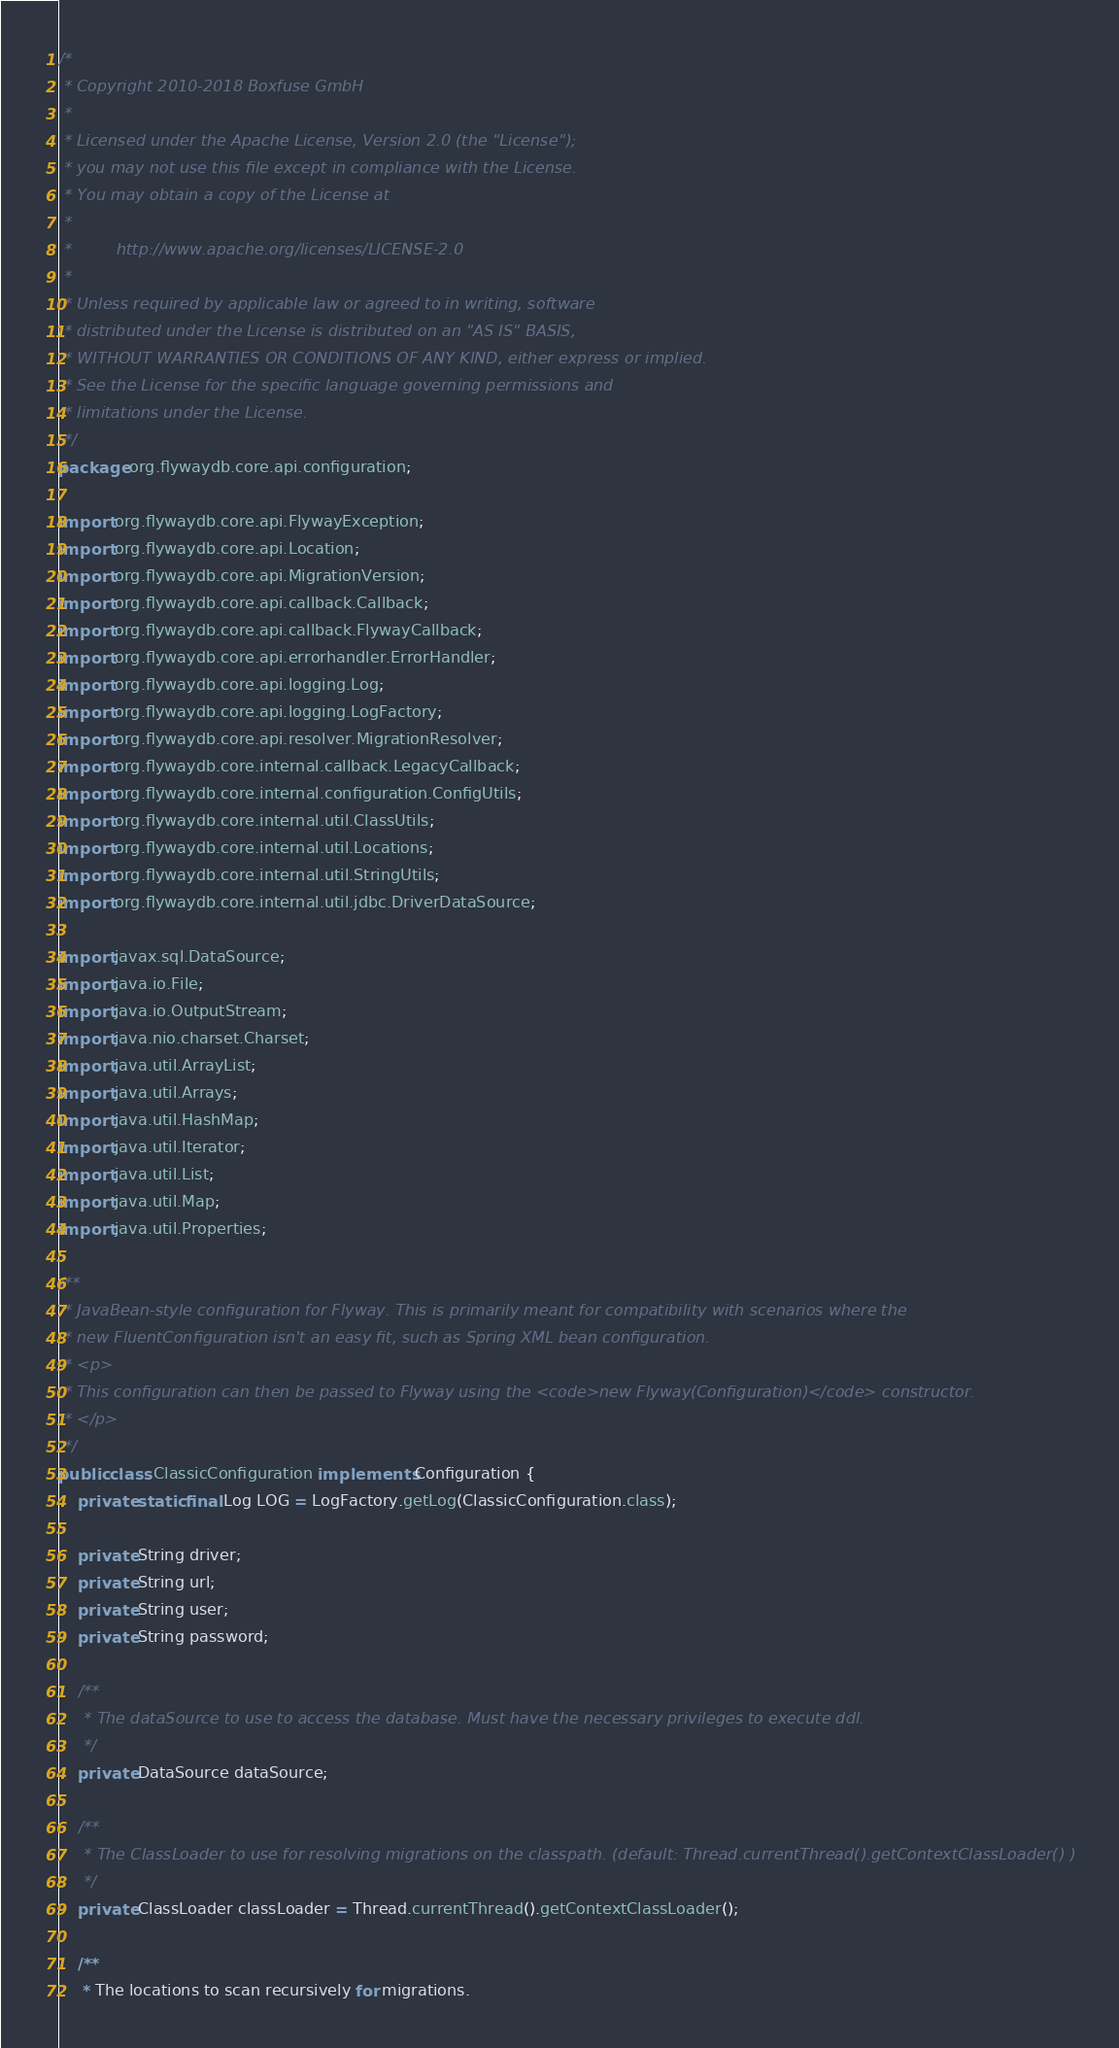Convert code to text. <code><loc_0><loc_0><loc_500><loc_500><_Java_>/*
 * Copyright 2010-2018 Boxfuse GmbH
 *
 * Licensed under the Apache License, Version 2.0 (the "License");
 * you may not use this file except in compliance with the License.
 * You may obtain a copy of the License at
 *
 *         http://www.apache.org/licenses/LICENSE-2.0
 *
 * Unless required by applicable law or agreed to in writing, software
 * distributed under the License is distributed on an "AS IS" BASIS,
 * WITHOUT WARRANTIES OR CONDITIONS OF ANY KIND, either express or implied.
 * See the License for the specific language governing permissions and
 * limitations under the License.
 */
package org.flywaydb.core.api.configuration;

import org.flywaydb.core.api.FlywayException;
import org.flywaydb.core.api.Location;
import org.flywaydb.core.api.MigrationVersion;
import org.flywaydb.core.api.callback.Callback;
import org.flywaydb.core.api.callback.FlywayCallback;
import org.flywaydb.core.api.errorhandler.ErrorHandler;
import org.flywaydb.core.api.logging.Log;
import org.flywaydb.core.api.logging.LogFactory;
import org.flywaydb.core.api.resolver.MigrationResolver;
import org.flywaydb.core.internal.callback.LegacyCallback;
import org.flywaydb.core.internal.configuration.ConfigUtils;
import org.flywaydb.core.internal.util.ClassUtils;
import org.flywaydb.core.internal.util.Locations;
import org.flywaydb.core.internal.util.StringUtils;
import org.flywaydb.core.internal.util.jdbc.DriverDataSource;

import javax.sql.DataSource;
import java.io.File;
import java.io.OutputStream;
import java.nio.charset.Charset;
import java.util.ArrayList;
import java.util.Arrays;
import java.util.HashMap;
import java.util.Iterator;
import java.util.List;
import java.util.Map;
import java.util.Properties;

/**
 * JavaBean-style configuration for Flyway. This is primarily meant for compatibility with scenarios where the
 * new FluentConfiguration isn't an easy fit, such as Spring XML bean configuration.
 * <p>
 * This configuration can then be passed to Flyway using the <code>new Flyway(Configuration)</code> constructor.
 * </p>
 */
public class ClassicConfiguration implements Configuration {
    private static final Log LOG = LogFactory.getLog(ClassicConfiguration.class);

    private String driver;
    private String url;
    private String user;
    private String password;

    /**
     * The dataSource to use to access the database. Must have the necessary privileges to execute ddl.
     */
    private DataSource dataSource;

    /**
     * The ClassLoader to use for resolving migrations on the classpath. (default: Thread.currentThread().getContextClassLoader() )
     */
    private ClassLoader classLoader = Thread.currentThread().getContextClassLoader();

    /**
     * The locations to scan recursively for migrations.</code> 